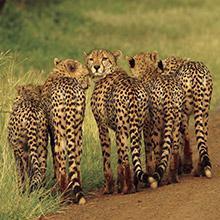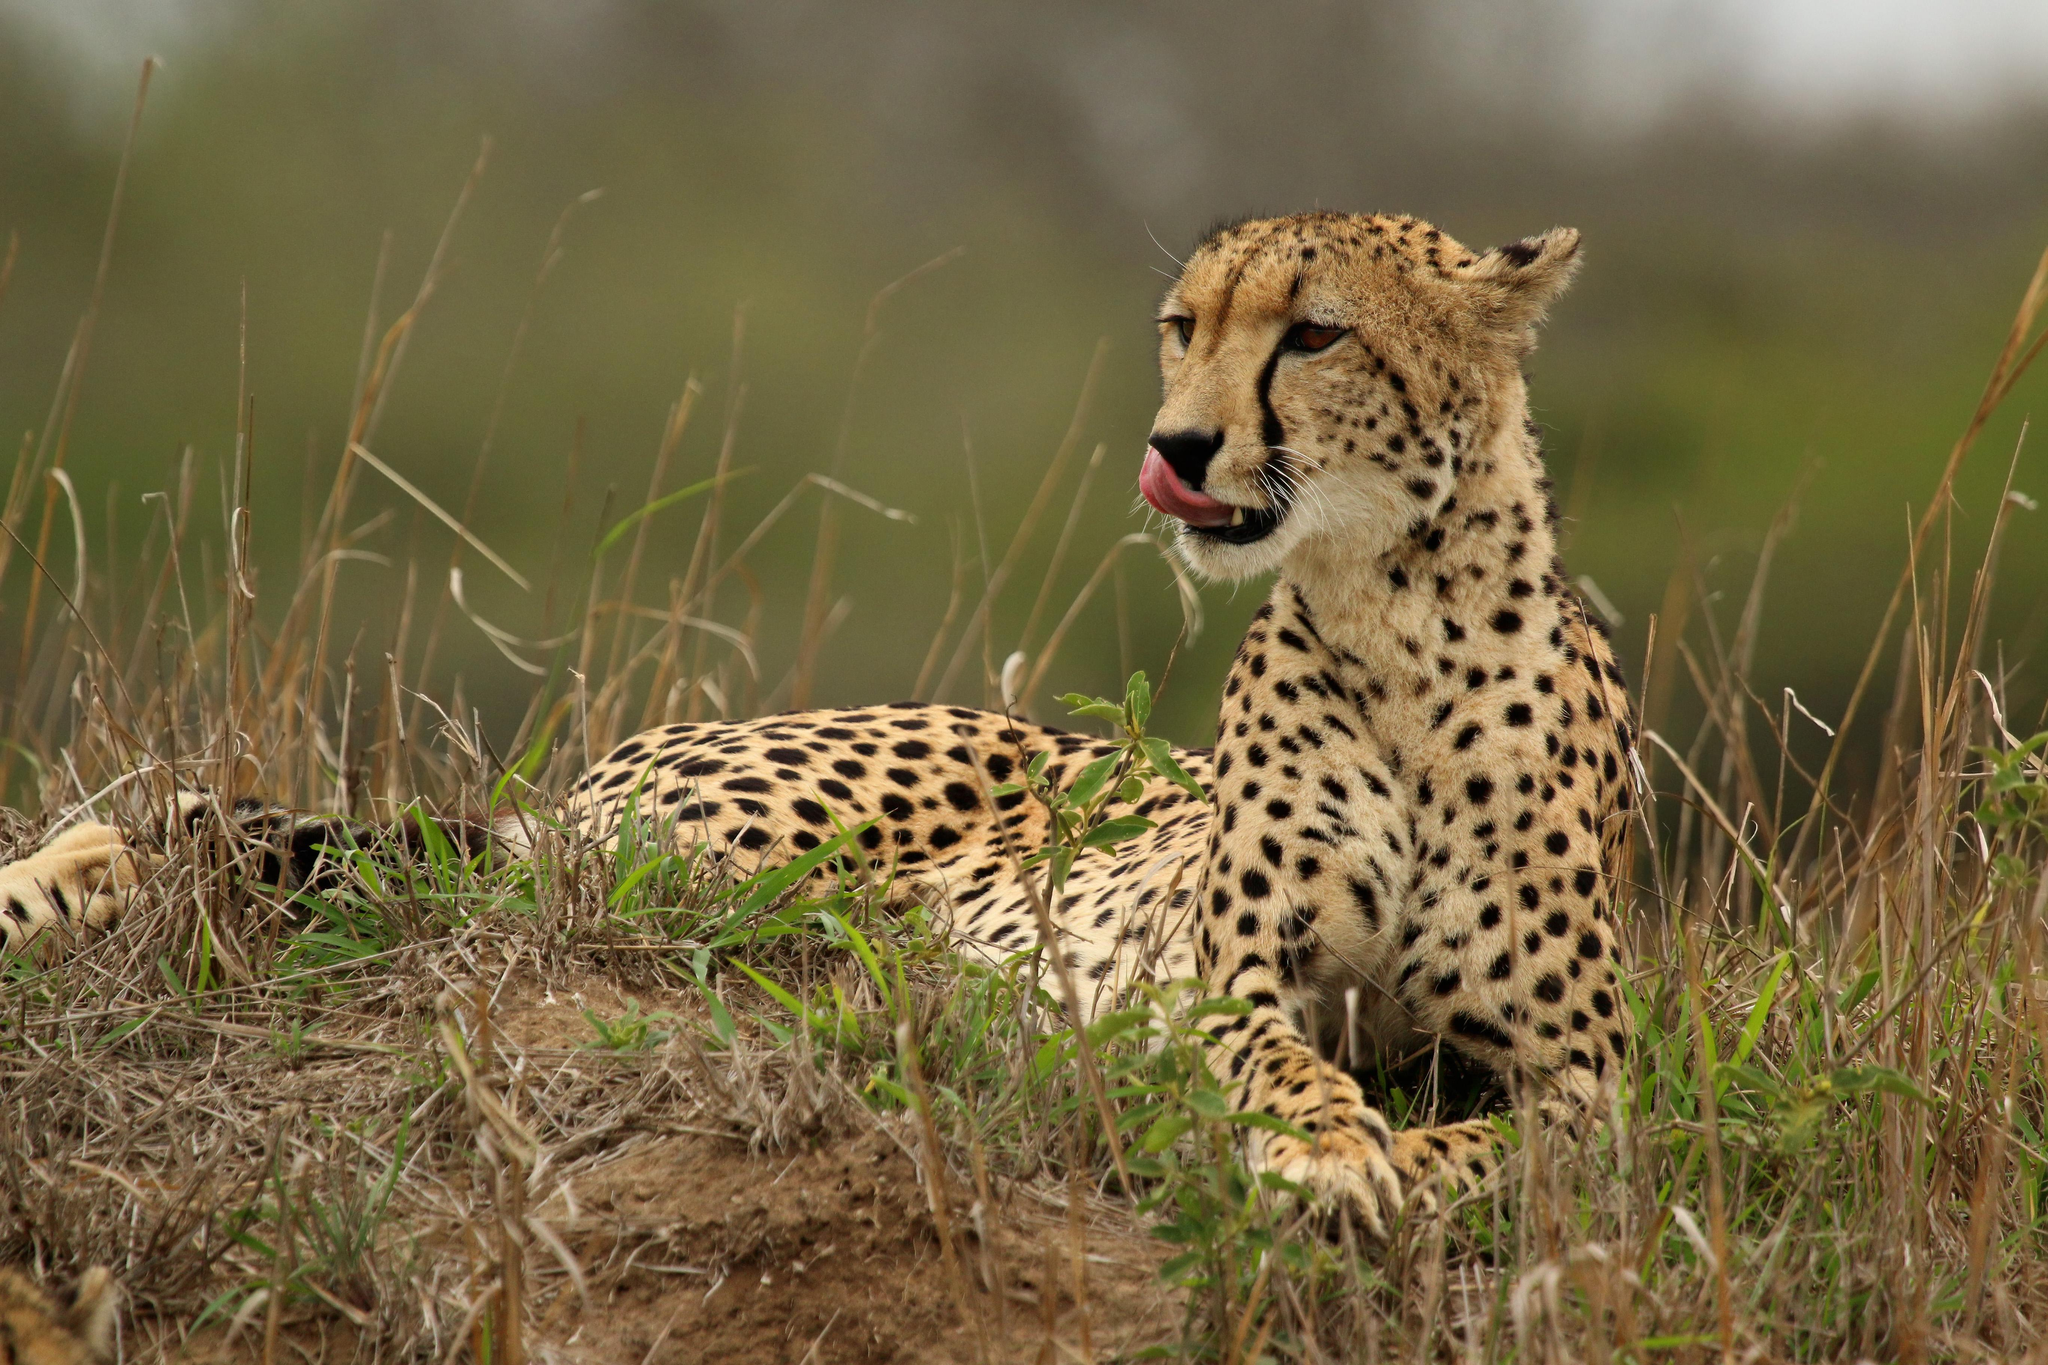The first image is the image on the left, the second image is the image on the right. Given the left and right images, does the statement "The image on the right has one lone cheetah sitting in the grass." hold true? Answer yes or no. Yes. The first image is the image on the left, the second image is the image on the right. Evaluate the accuracy of this statement regarding the images: "One image features baby cheetahs next to an adult cheetah". Is it true? Answer yes or no. No. 